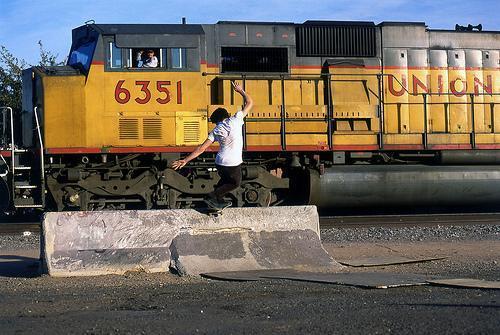How many boys are there?
Give a very brief answer. 1. 